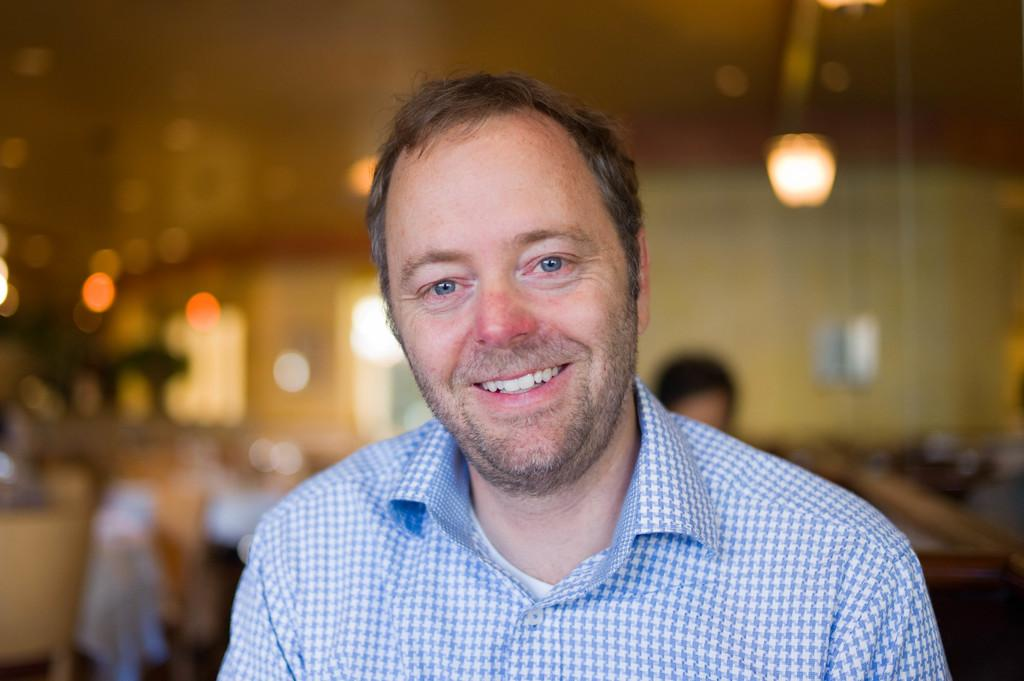Who is present in the image? There is a man in the image. What is the man doing in the image? The man is smiling in the image. Can you describe the background of the image? The background of the image is blurred, and lights, a wall, a person's head, and other objects are visible. What type of ball is being used by the man in the image? There is no ball present in the image; the man is simply smiling. What kind of experience is the man having in the image? The image does not provide information about the man's experience; it only shows him smiling. 